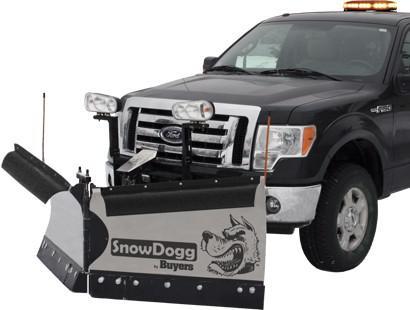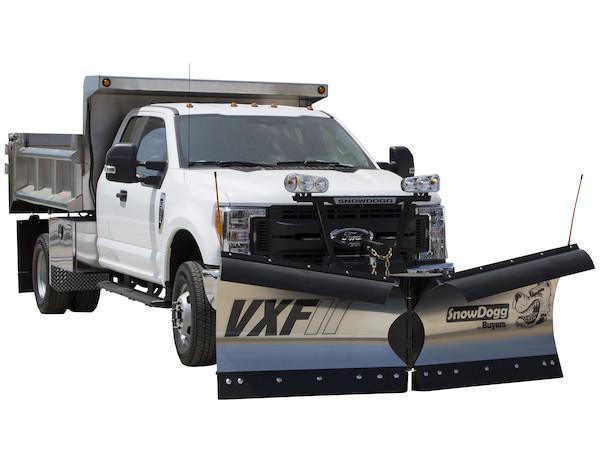The first image is the image on the left, the second image is the image on the right. Analyze the images presented: Is the assertion "A truck is red." valid? Answer yes or no. No. The first image is the image on the left, the second image is the image on the right. Analyze the images presented: Is the assertion "At least one of the plows is made up of two separate panels with a gap between them." valid? Answer yes or no. Yes. 